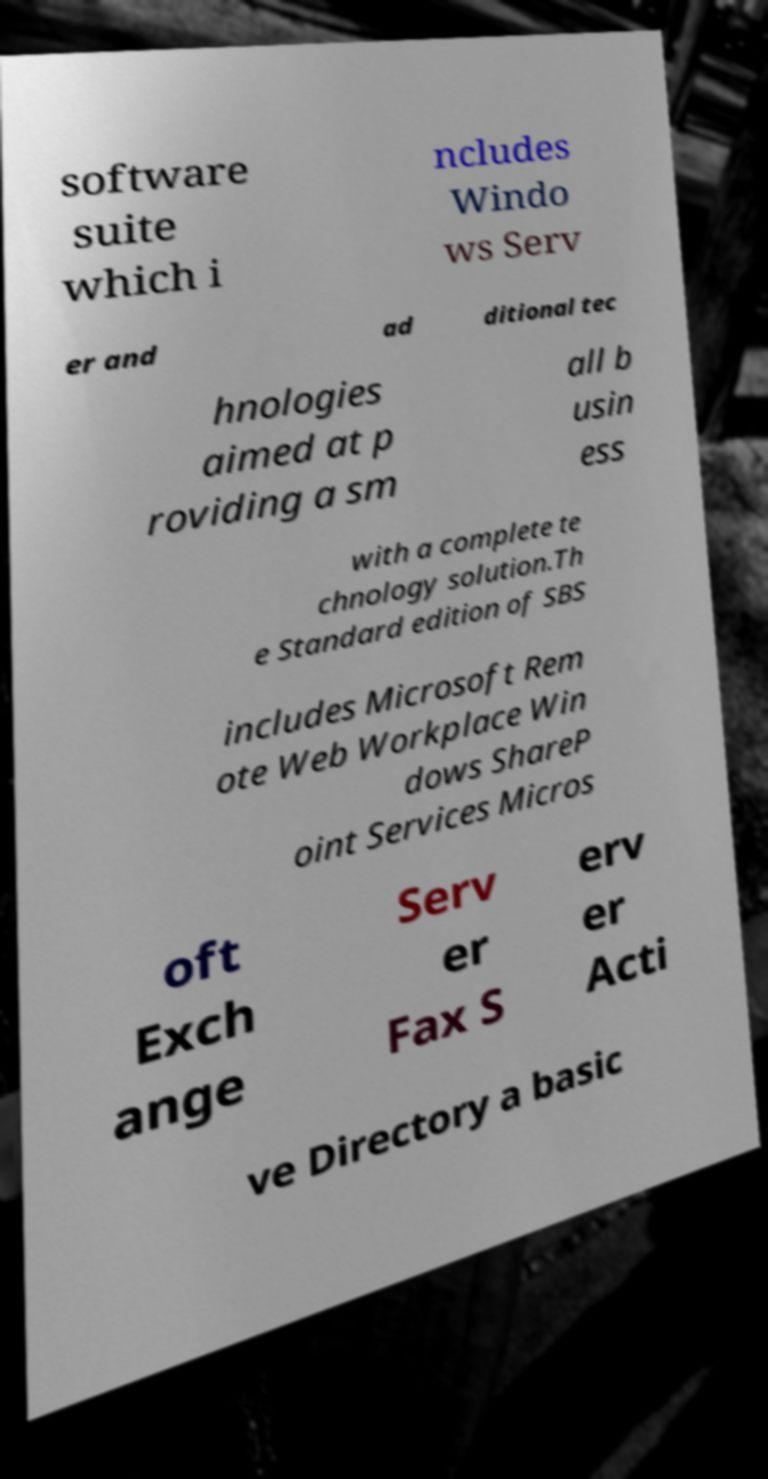For documentation purposes, I need the text within this image transcribed. Could you provide that? software suite which i ncludes Windo ws Serv er and ad ditional tec hnologies aimed at p roviding a sm all b usin ess with a complete te chnology solution.Th e Standard edition of SBS includes Microsoft Rem ote Web Workplace Win dows ShareP oint Services Micros oft Exch ange Serv er Fax S erv er Acti ve Directory a basic 